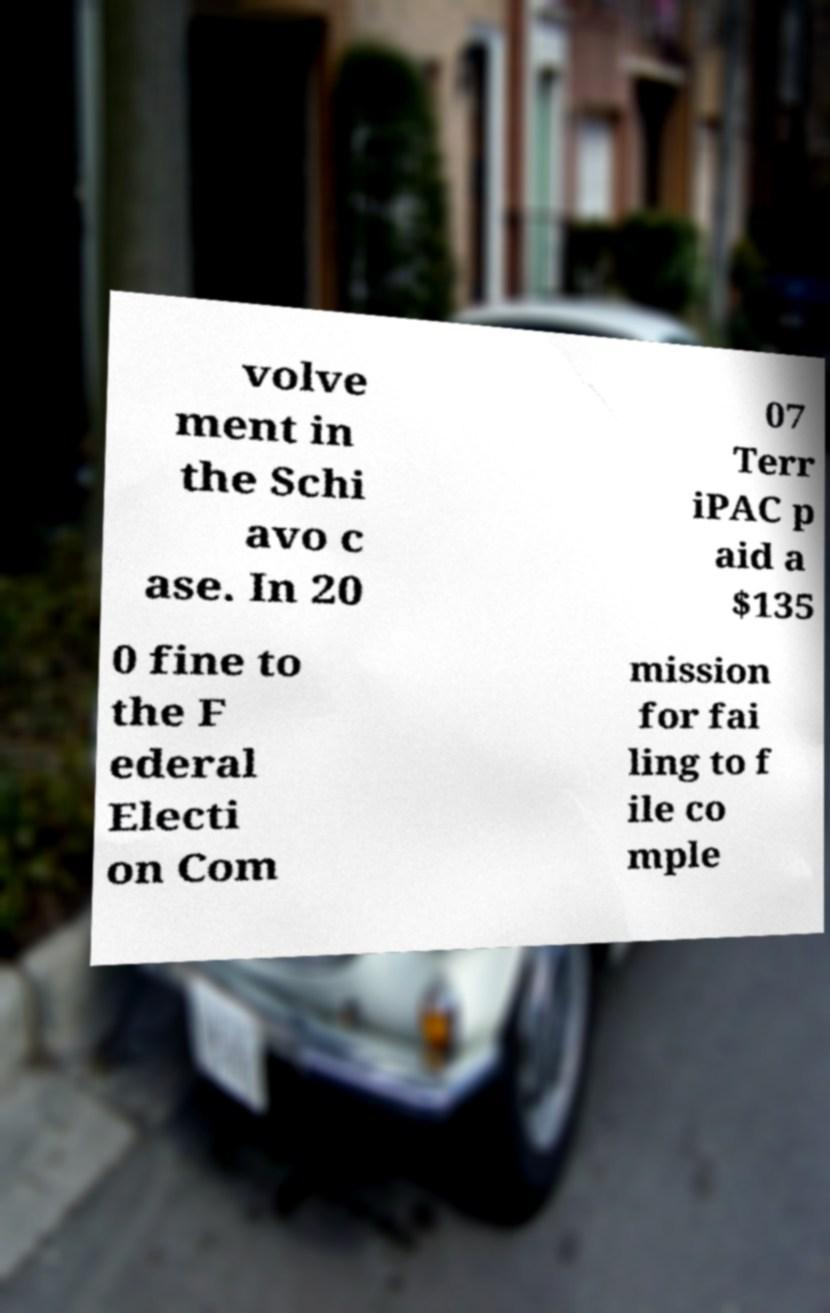Can you read and provide the text displayed in the image?This photo seems to have some interesting text. Can you extract and type it out for me? volve ment in the Schi avo c ase. In 20 07 Terr iPAC p aid a $135 0 fine to the F ederal Electi on Com mission for fai ling to f ile co mple 